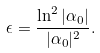<formula> <loc_0><loc_0><loc_500><loc_500>\epsilon = \frac { \ln ^ { 2 } | \alpha _ { 0 } | } { | \alpha _ { 0 } | ^ { 2 } } .</formula> 